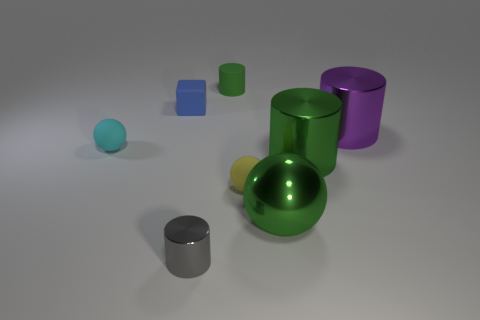Is there another cylinder that has the same color as the small shiny cylinder? no 